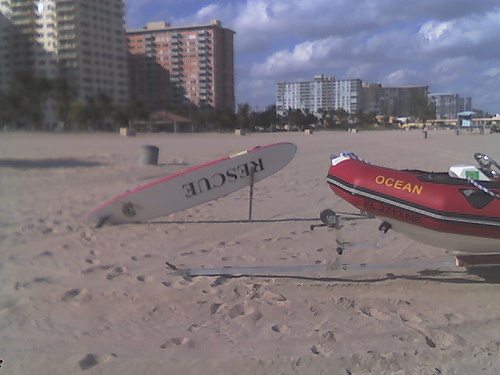Describe the objects in this image and their specific colors. I can see boat in lightgray, gray, maroon, and brown tones, surfboard in lightgray, gray, and black tones, people in lightgray and gray tones, and people in lightgray and gray tones in this image. 